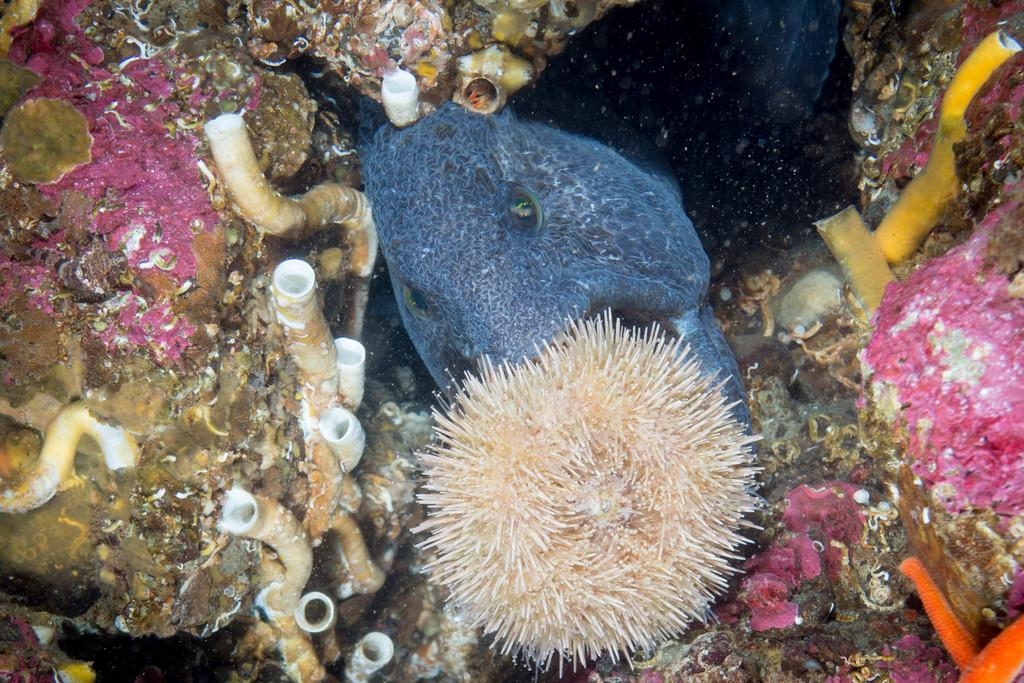Where was the image taken? The image was clicked inside the water. What can be seen in the water in the image? There are coral reefs, fish, and other living objects in the image. What is the primary element visible in the image? The water is visible in the image. What type of men can be seen walking on the street in the image? There are no men or streets present in the image; it features underwater scenery with coral reefs, fish, and other living objects. 